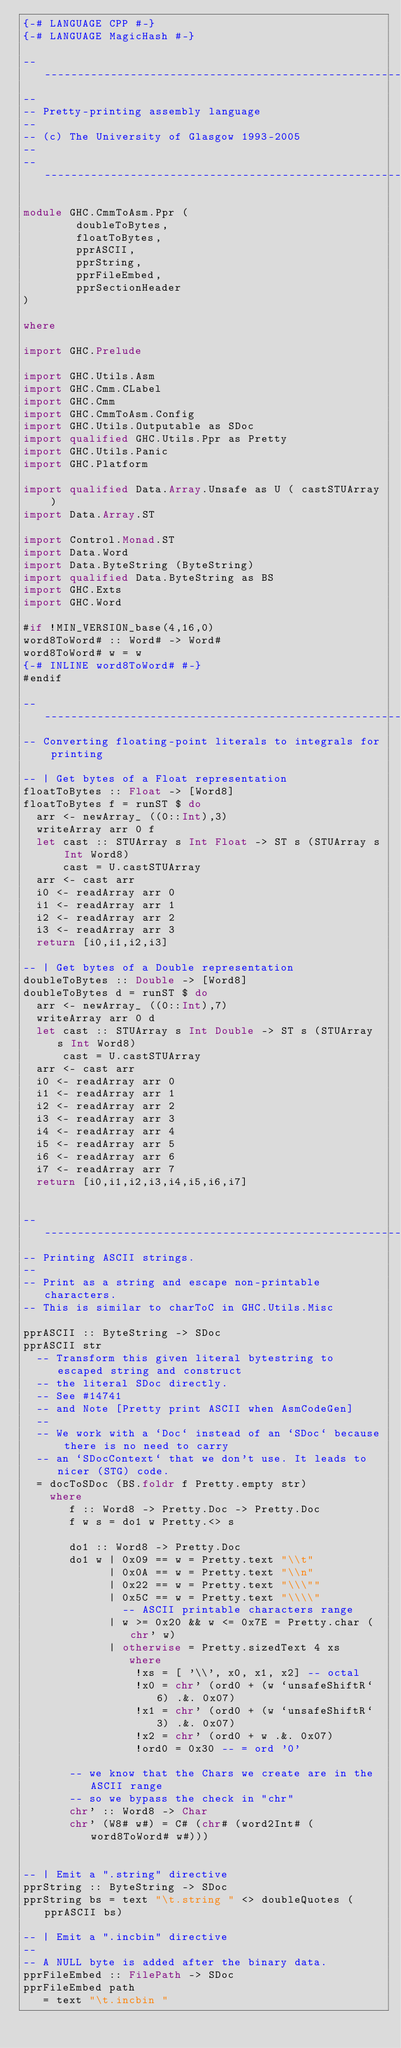<code> <loc_0><loc_0><loc_500><loc_500><_Haskell_>{-# LANGUAGE CPP #-}
{-# LANGUAGE MagicHash #-}

-----------------------------------------------------------------------------
--
-- Pretty-printing assembly language
--
-- (c) The University of Glasgow 1993-2005
--
-----------------------------------------------------------------------------

module GHC.CmmToAsm.Ppr (
        doubleToBytes,
        floatToBytes,
        pprASCII,
        pprString,
        pprFileEmbed,
        pprSectionHeader
)

where

import GHC.Prelude

import GHC.Utils.Asm
import GHC.Cmm.CLabel
import GHC.Cmm
import GHC.CmmToAsm.Config
import GHC.Utils.Outputable as SDoc
import qualified GHC.Utils.Ppr as Pretty
import GHC.Utils.Panic
import GHC.Platform

import qualified Data.Array.Unsafe as U ( castSTUArray )
import Data.Array.ST

import Control.Monad.ST
import Data.Word
import Data.ByteString (ByteString)
import qualified Data.ByteString as BS
import GHC.Exts
import GHC.Word

#if !MIN_VERSION_base(4,16,0)
word8ToWord# :: Word# -> Word#
word8ToWord# w = w
{-# INLINE word8ToWord# #-}
#endif

-- -----------------------------------------------------------------------------
-- Converting floating-point literals to integrals for printing

-- | Get bytes of a Float representation
floatToBytes :: Float -> [Word8]
floatToBytes f = runST $ do
  arr <- newArray_ ((0::Int),3)
  writeArray arr 0 f
  let cast :: STUArray s Int Float -> ST s (STUArray s Int Word8)
      cast = U.castSTUArray
  arr <- cast arr
  i0 <- readArray arr 0
  i1 <- readArray arr 1
  i2 <- readArray arr 2
  i3 <- readArray arr 3
  return [i0,i1,i2,i3]

-- | Get bytes of a Double representation
doubleToBytes :: Double -> [Word8]
doubleToBytes d = runST $ do
  arr <- newArray_ ((0::Int),7)
  writeArray arr 0 d
  let cast :: STUArray s Int Double -> ST s (STUArray s Int Word8)
      cast = U.castSTUArray
  arr <- cast arr
  i0 <- readArray arr 0
  i1 <- readArray arr 1
  i2 <- readArray arr 2
  i3 <- readArray arr 3
  i4 <- readArray arr 4
  i5 <- readArray arr 5
  i6 <- readArray arr 6
  i7 <- readArray arr 7
  return [i0,i1,i2,i3,i4,i5,i6,i7]


-- ---------------------------------------------------------------------------
-- Printing ASCII strings.
--
-- Print as a string and escape non-printable characters.
-- This is similar to charToC in GHC.Utils.Misc

pprASCII :: ByteString -> SDoc
pprASCII str
  -- Transform this given literal bytestring to escaped string and construct
  -- the literal SDoc directly.
  -- See #14741
  -- and Note [Pretty print ASCII when AsmCodeGen]
  --
  -- We work with a `Doc` instead of an `SDoc` because there is no need to carry
  -- an `SDocContext` that we don't use. It leads to nicer (STG) code.
  = docToSDoc (BS.foldr f Pretty.empty str)
    where
       f :: Word8 -> Pretty.Doc -> Pretty.Doc
       f w s = do1 w Pretty.<> s

       do1 :: Word8 -> Pretty.Doc
       do1 w | 0x09 == w = Pretty.text "\\t"
             | 0x0A == w = Pretty.text "\\n"
             | 0x22 == w = Pretty.text "\\\""
             | 0x5C == w = Pretty.text "\\\\"
               -- ASCII printable characters range
             | w >= 0x20 && w <= 0x7E = Pretty.char (chr' w)
             | otherwise = Pretty.sizedText 4 xs
                where
                 !xs = [ '\\', x0, x1, x2] -- octal
                 !x0 = chr' (ord0 + (w `unsafeShiftR` 6) .&. 0x07)
                 !x1 = chr' (ord0 + (w `unsafeShiftR` 3) .&. 0x07)
                 !x2 = chr' (ord0 + w .&. 0x07)
                 !ord0 = 0x30 -- = ord '0'

       -- we know that the Chars we create are in the ASCII range
       -- so we bypass the check in "chr"
       chr' :: Word8 -> Char
       chr' (W8# w#) = C# (chr# (word2Int# (word8ToWord# w#)))


-- | Emit a ".string" directive
pprString :: ByteString -> SDoc
pprString bs = text "\t.string " <> doubleQuotes (pprASCII bs)

-- | Emit a ".incbin" directive
--
-- A NULL byte is added after the binary data.
pprFileEmbed :: FilePath -> SDoc
pprFileEmbed path
   = text "\t.incbin "</code> 